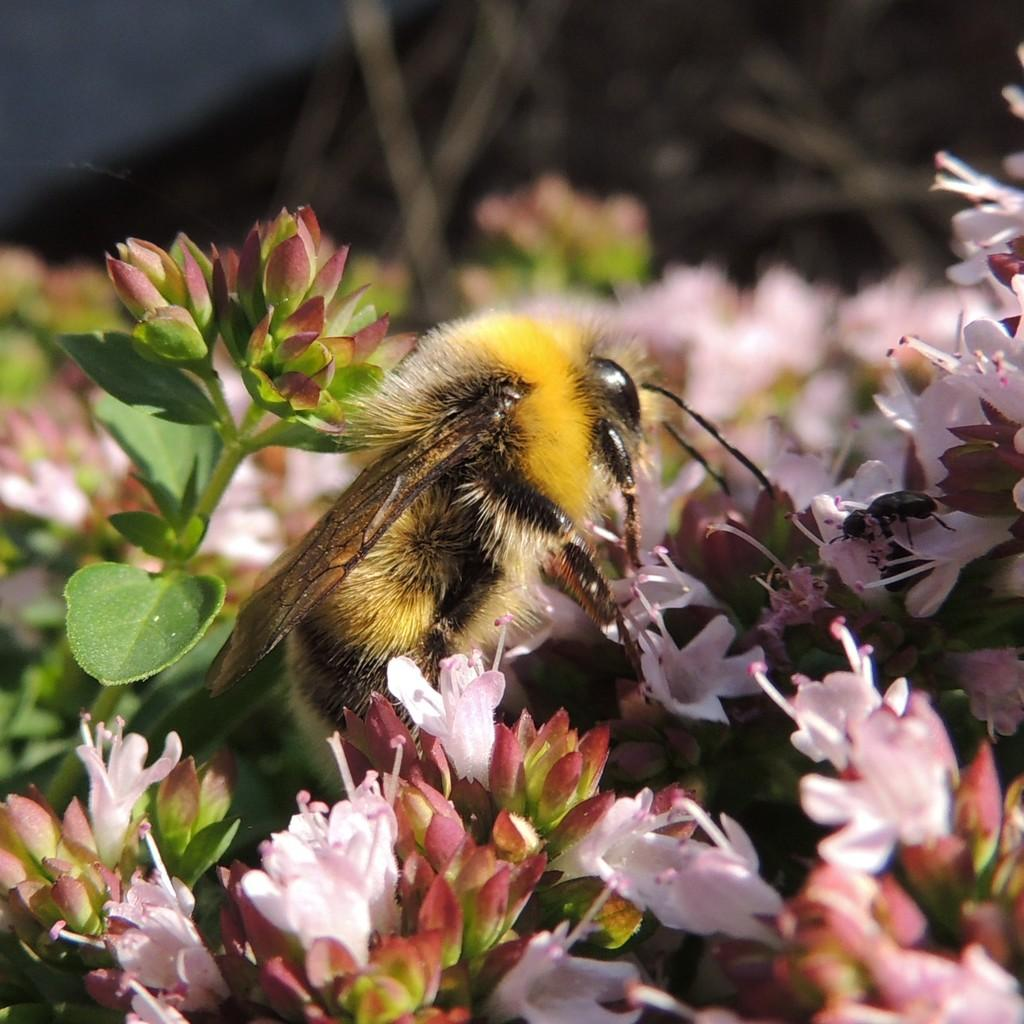What type of living organisms can be seen in the image? Insects can be seen in the image. What type of plants are in the image? Flowers and leaves are in the image. Are there any unopened flowers in the image? Yes, there are buds in the image. How would you describe the background of the image? The background of the image is blurred. What type of vest is the insect wearing in the image? There is no vest present in the image, as insects do not wear clothing. Can you tell me how the insect is helping the flowers in the image? Insects do not help flowers in the way the question implies; they may interact with flowers in various ways, such as pollination, but they do not provide assistance in the same manner as humans. 